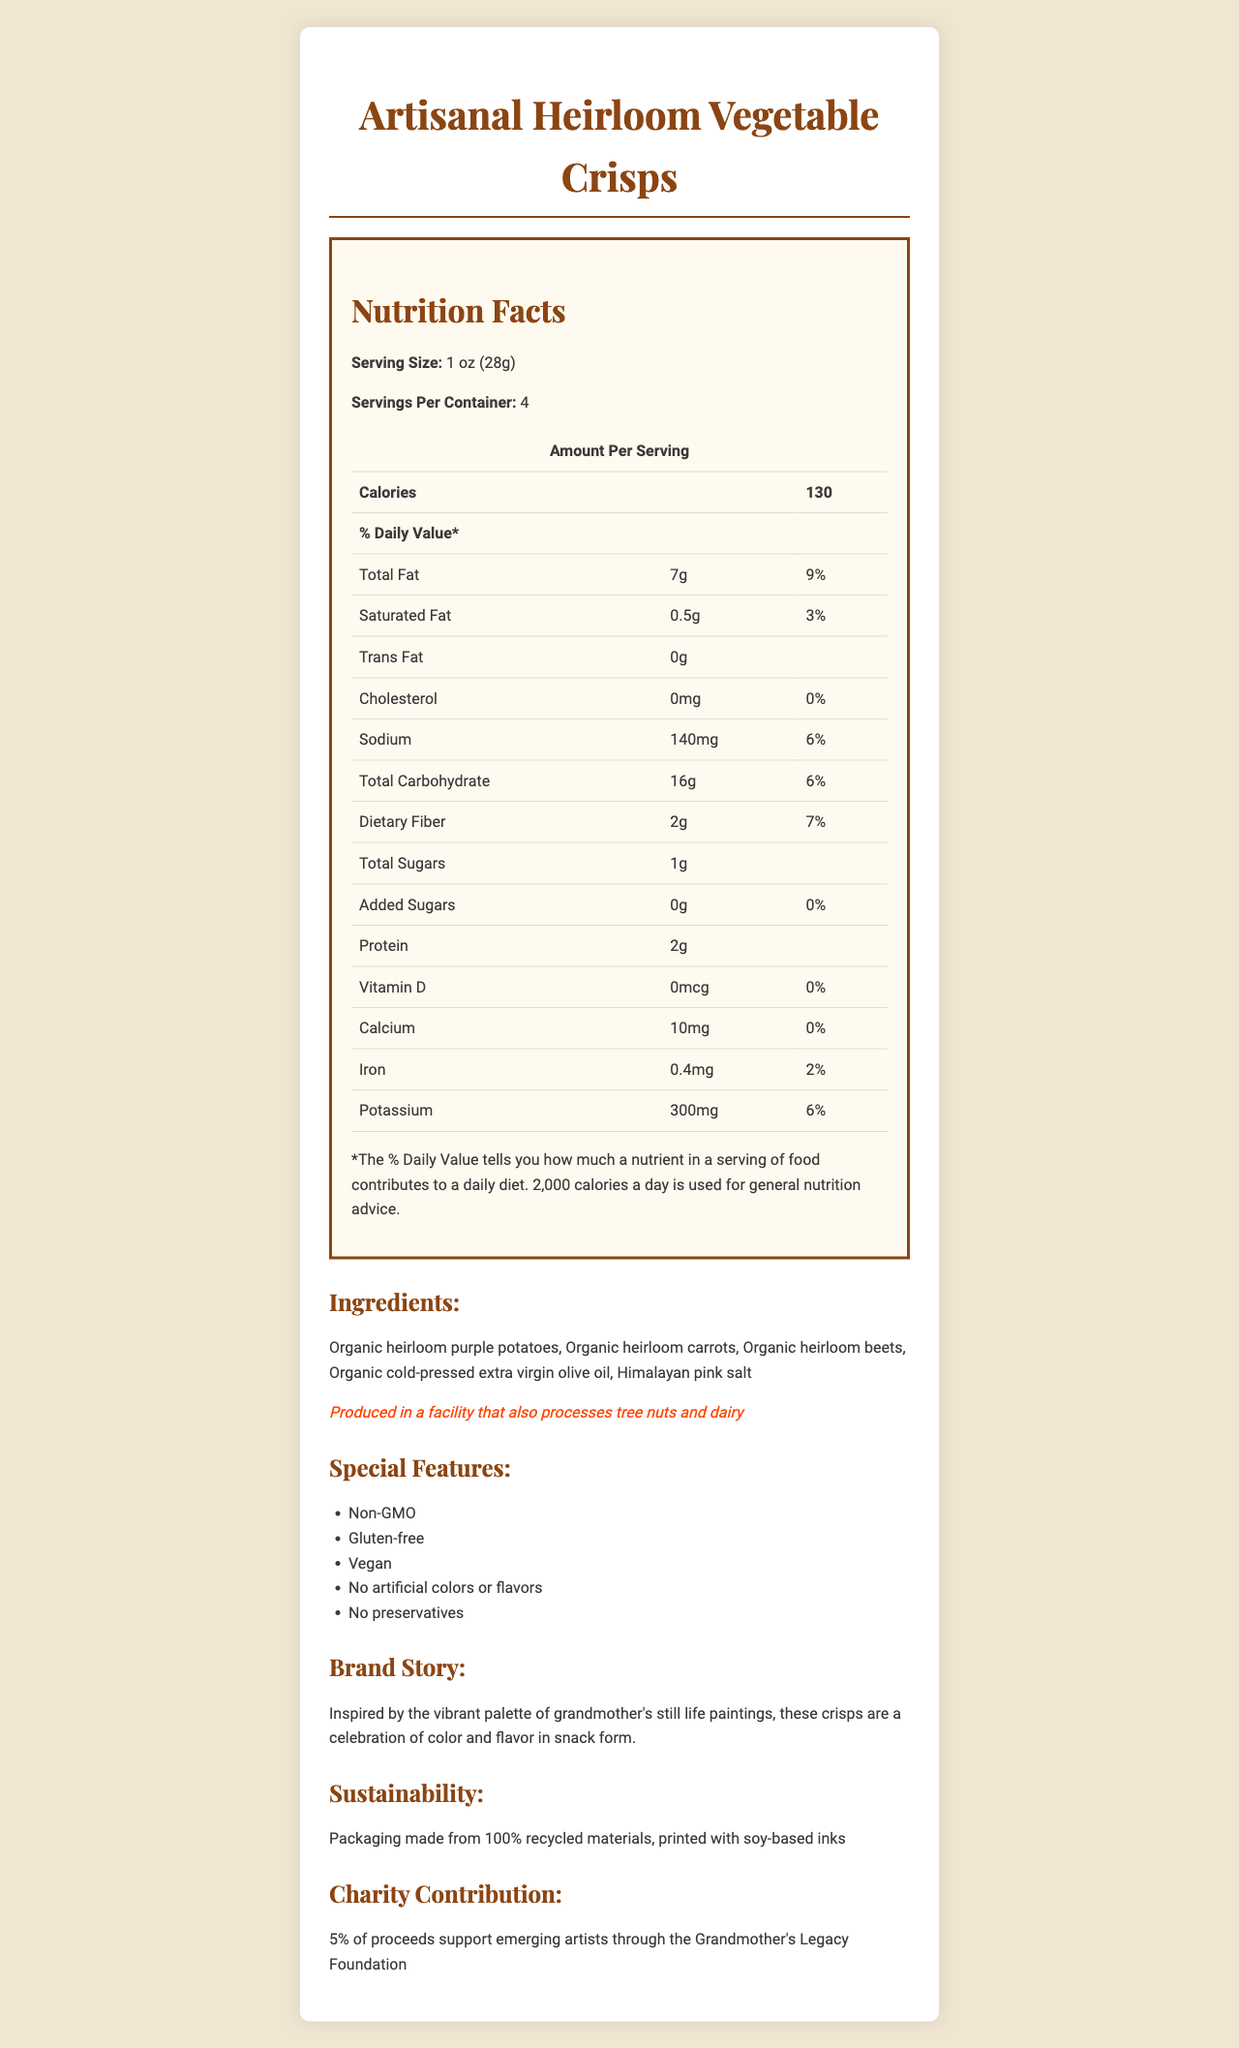who is responsible for producing the snacks? The document does not provide specific information regarding the producer of the snacks.
Answer: I don't know what is the serving size of the crisps? The document states that the serving size is 1 oz (28g).
Answer: 1 oz (28g) how many calories are in one serving? The document states that there are 130 calories per serving.
Answer: 130 How much dietary fiber is in one serving, and what percentage of the daily value does it provide? The document indicates that one serving contains 2g of dietary fiber, which is 7% of the daily value.
Answer: 2g, 7% what type of oil is used in the crisps? The ingredients list includes "Organic cold-pressed extra virgin olive oil."
Answer: Organic cold-pressed extra virgin olive oil what are the top benefits mentioned on the label? A. Gluten-free B. Vegan C. Non-GMO D. Contains preservatives The document lists "Non-GMO," "Gluten-free," and "Vegan" as special features. It also mentions "No preservatives," so option D is incorrect.
Answer: A, B, C which mineral has the highest daily value percentage in the crisps? A. Calcium B. Iron C. Potassium D. Sodium The daily value percentages listed are 0% for Calcium, 2% for Iron, and 6% for both Potassium and Sodium. Potassium and Sodium have the same highest percentage, but the question specifically asks for one mineral, leading to a correct answer of C. Potassium.
Answer: C. Potassium are these crisps suitable for vegans? The document states that the crisps are vegan under special features.
Answer: Yes describe the main idea of the document. This summary captures all the key elements included in the document: nutrition details, ingredients, allergen info, special features, brand story, sustainability, and charity contributions.
Answer: The document provides detailed nutrition facts, ingredients, allergen information, special features, brand story, sustainability initiatives, and charity contributions for Artisanal Heirloom Vegetable Crisps, a preservative-free snack designed to be both nutritious and environmentally friendly. is iron content in these crisps higher than calcium? Iron content is 0.4mg, whereas calcium content is 10mg; however, the daily value of iron is 2%, while calcium's daily value is 0%, indicating that iron content is proportionally higher compared to its daily value.
Answer: Yes what percentage of daily value of Vitamin D does one serving provide? The document states that the amount of Vitamin D per serving is 0mcg, which is 0% of the daily value.
Answer: 0% how many servings are in one container? The document states that there are 4 servings per container.
Answer: 4 where is the packaging made from? The sustainability section indicates the packaging is made from 100% recycled materials and printed with soy-based inks.
Answer: 100% recycled materials, printed with soy-based inks what is the charity contribution provided by this product? The document states that 5% of the proceeds support emerging artists via the Grandmother's Legacy Foundation.
Answer: 5% of proceeds support emerging artists through the Grandmother's Legacy Foundation if someone is allergic to tree nuts, is it safe for them to consume these crisps? The document notes that the crisps are produced in a facility that also processes tree nuts, which might pose a risk to individuals with a tree nut allergy.
Answer: I don't know 